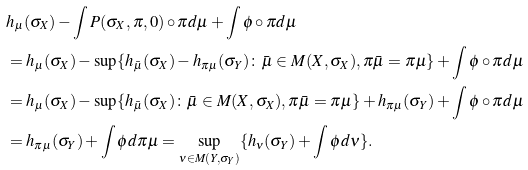<formula> <loc_0><loc_0><loc_500><loc_500>& h _ { \mu } ( \sigma _ { X } ) - \int P ( \sigma _ { X } , \pi , 0 ) \circ \pi d { \mu } + \int \phi \circ \pi d { \mu } \\ & = h _ { \mu } ( \sigma _ { X } ) - \sup \{ h _ { \bar { \mu } } ( \sigma _ { X } ) - h _ { \pi { \mu } } ( \sigma _ { Y } ) \colon \bar { \mu } \in M ( X , \sigma _ { X } ) , \pi { \bar { \mu } } = \pi { \mu } \} + \int \phi \circ \pi d { \mu } \\ & = h _ { \mu } ( \sigma _ { X } ) - \sup \{ h _ { \bar { \mu } } ( \sigma _ { X } ) \colon \bar { \mu } \in M ( X , \sigma _ { X } ) , \pi { \bar { \mu } } = \pi { \mu } \} + h _ { \pi { \mu } } ( \sigma _ { Y } ) + \int \phi \circ \pi d { \mu } \\ & = h _ { \pi { \mu } } ( \sigma _ { Y } ) + \int \phi d { \pi \mu } = \sup _ { \nu \in M ( Y , \sigma _ { Y } ) } \{ h _ { \nu } ( \sigma _ { Y } ) + \int \phi d \nu \} .</formula> 